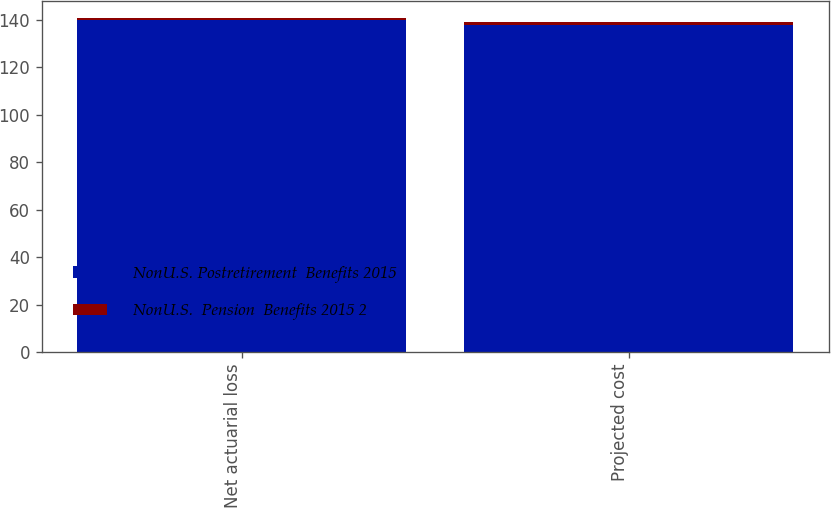<chart> <loc_0><loc_0><loc_500><loc_500><stacked_bar_chart><ecel><fcel>Net actuarial loss<fcel>Projected cost<nl><fcel>NonU.S. Postretirement  Benefits 2015<fcel>140<fcel>138<nl><fcel>NonU.S.  Pension  Benefits 2015 2<fcel>1<fcel>1<nl></chart> 